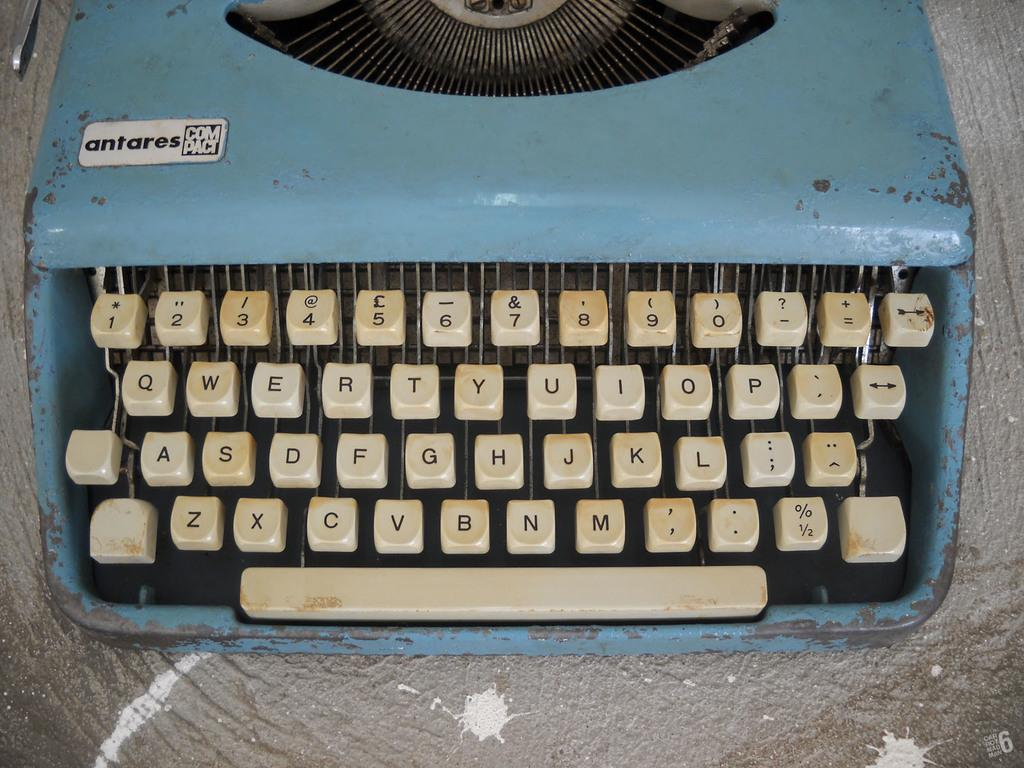<image>
Write a terse but informative summary of the picture. An old blue antares compact typewriter with all keys intact. 